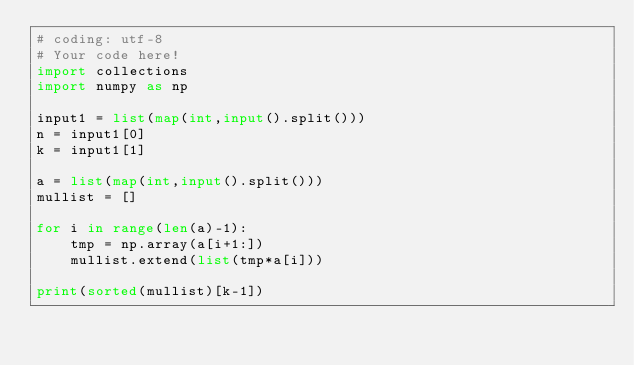Convert code to text. <code><loc_0><loc_0><loc_500><loc_500><_Python_># coding: utf-8
# Your code here!
import collections
import numpy as np

input1 = list(map(int,input().split()))
n = input1[0]
k = input1[1]

a = list(map(int,input().split()))
mullist = []

for i in range(len(a)-1):
    tmp = np.array(a[i+1:])
    mullist.extend(list(tmp*a[i]))

print(sorted(mullist)[k-1])</code> 